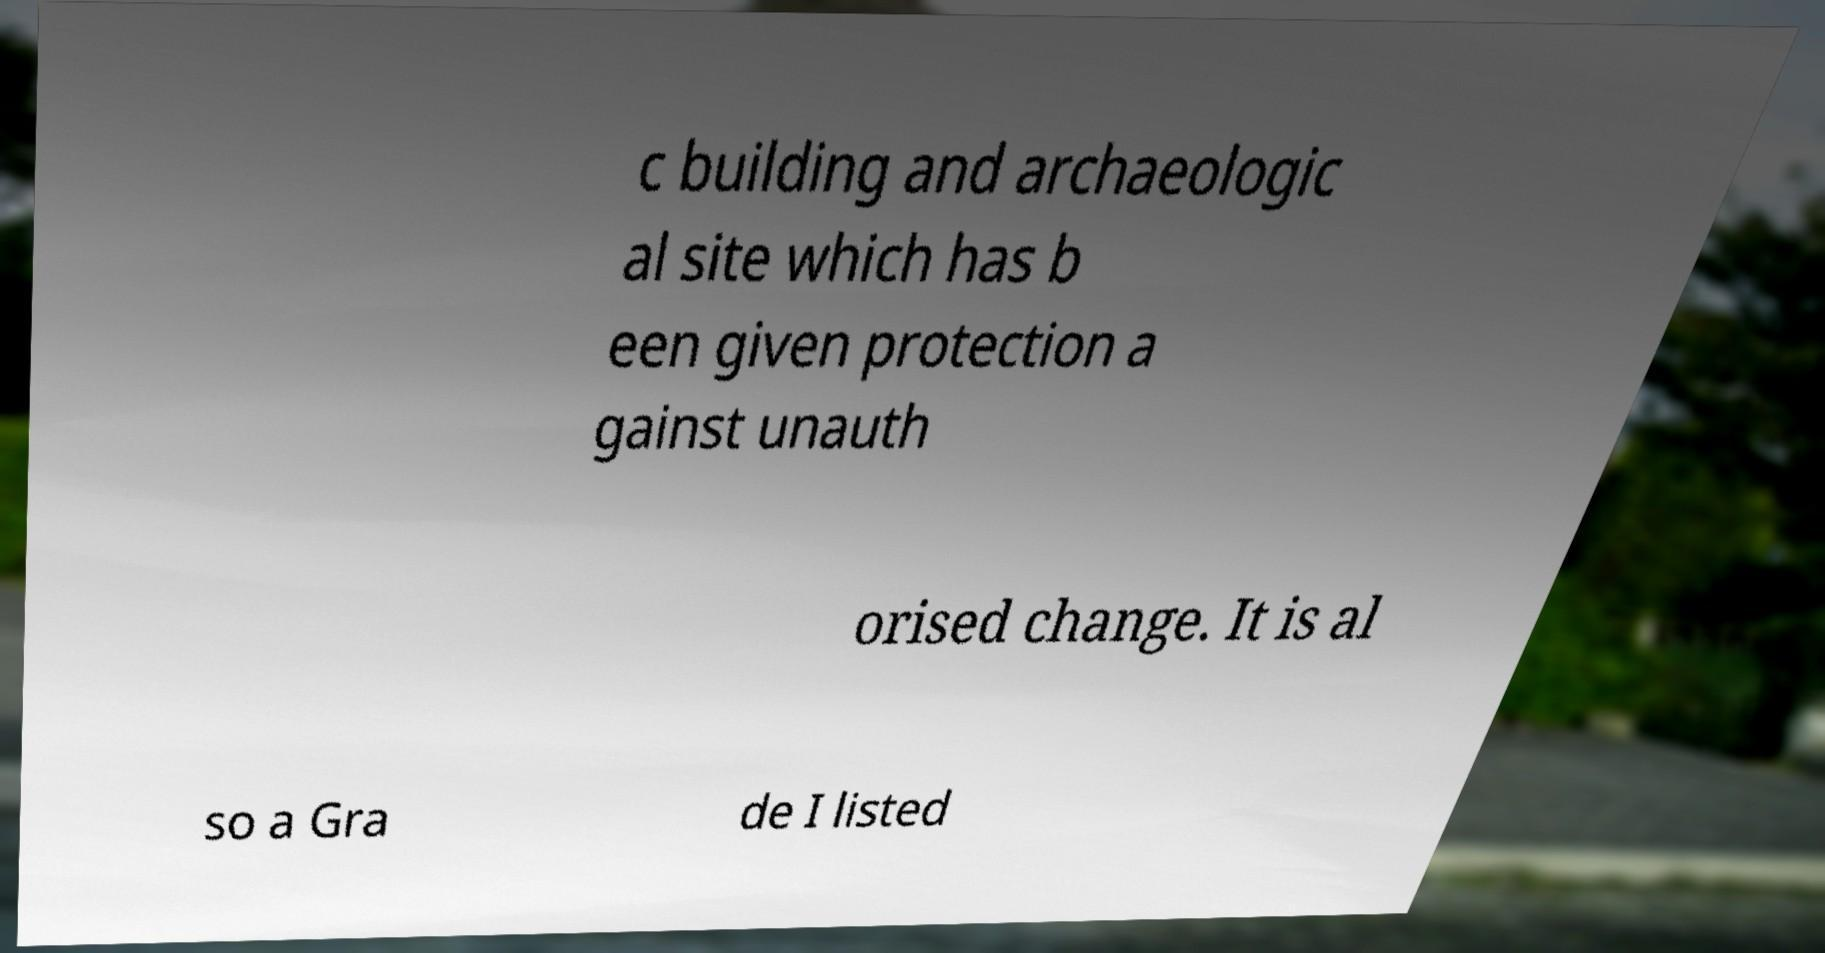Please identify and transcribe the text found in this image. c building and archaeologic al site which has b een given protection a gainst unauth orised change. It is al so a Gra de I listed 